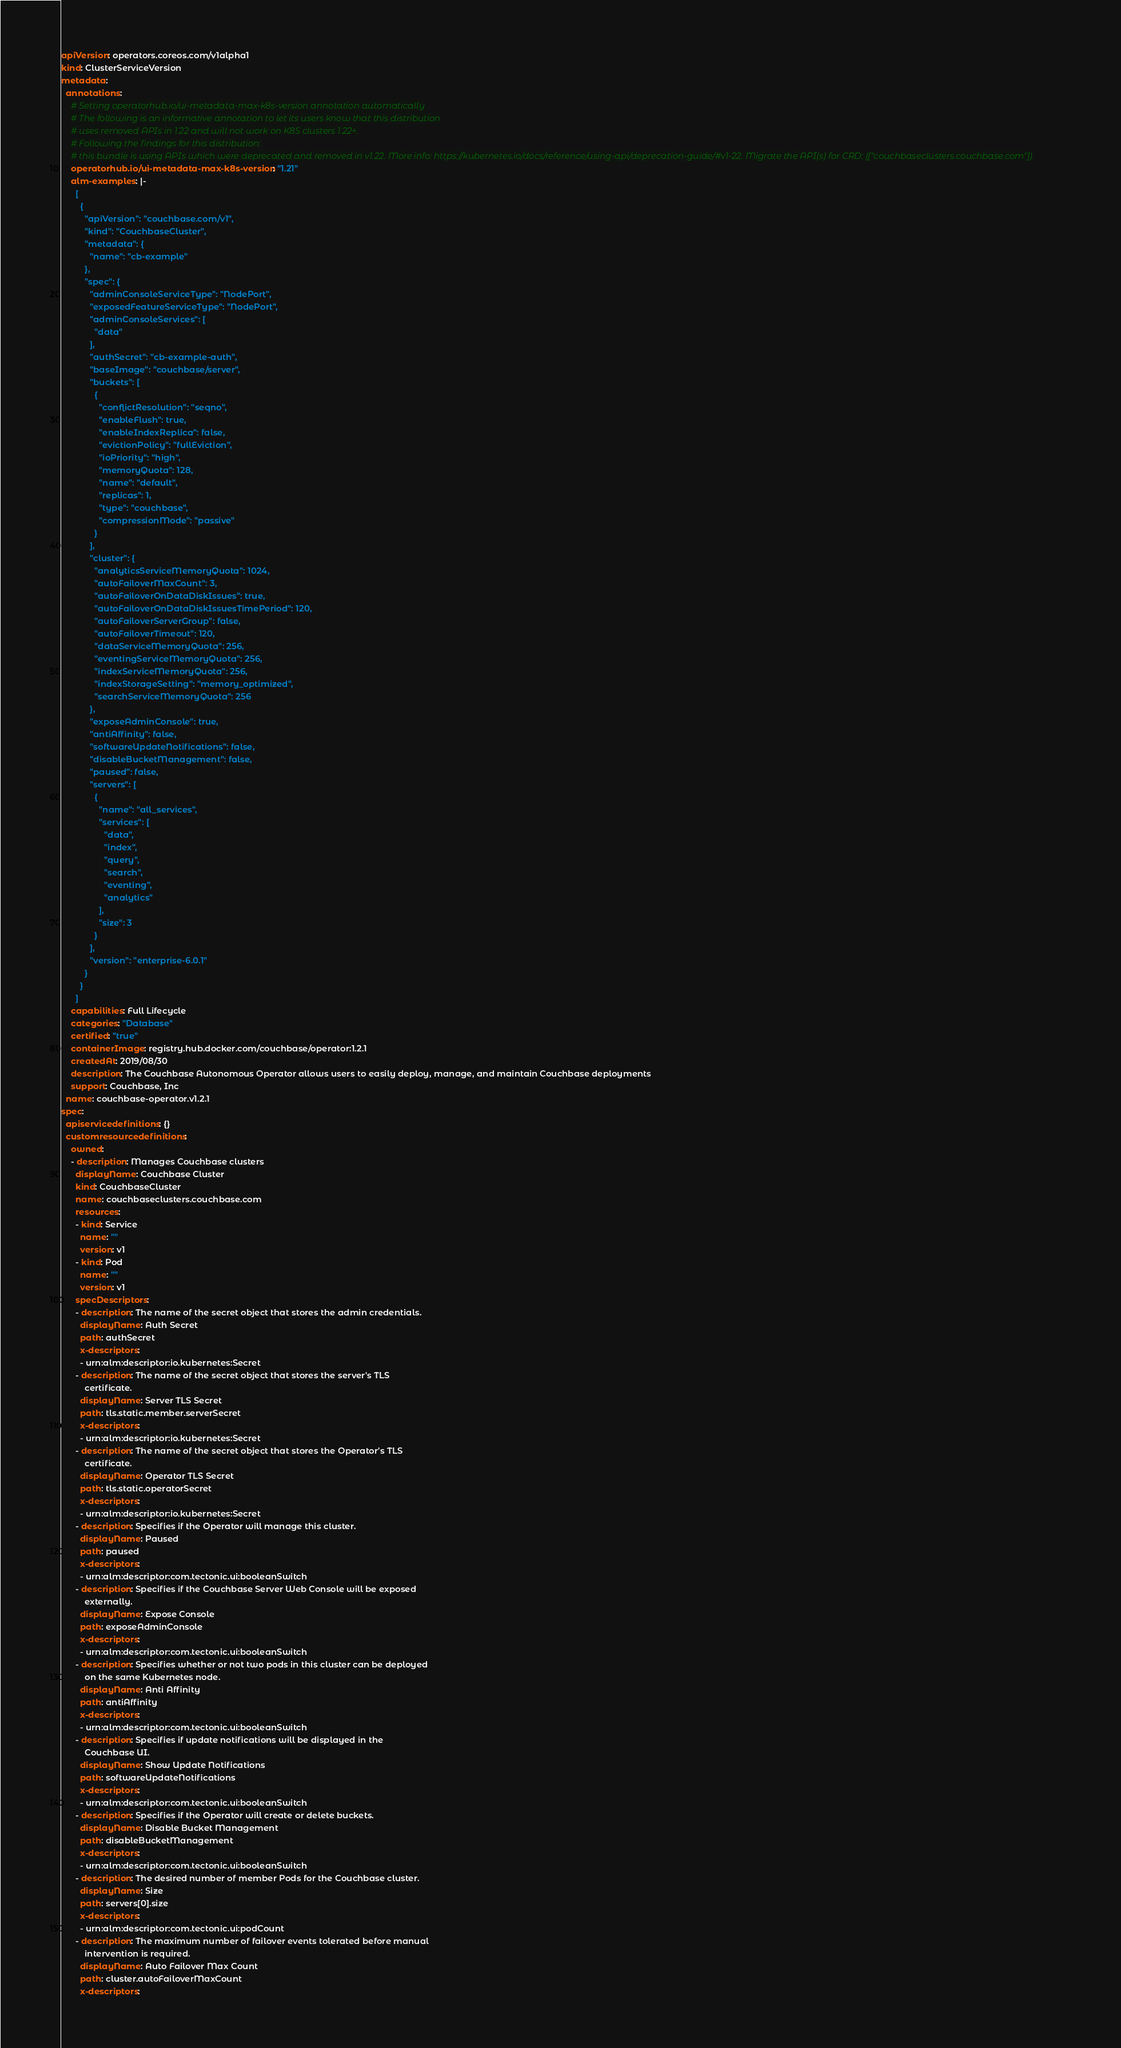Convert code to text. <code><loc_0><loc_0><loc_500><loc_500><_YAML_>apiVersion: operators.coreos.com/v1alpha1
kind: ClusterServiceVersion
metadata:
  annotations:
    # Setting operatorhub.io/ui-metadata-max-k8s-version annotation automatically
    # The following is an informative annotation to let its users know that this distribution
    # uses removed APIs in 1.22 and will not work on K8S clusters 1.22+.
    # Following the findings for this distribution:
    # this bundle is using APIs which were deprecated and removed in v1.22. More info: https://kubernetes.io/docs/reference/using-api/deprecation-guide/#v1-22. Migrate the API(s) for CRD: (["couchbaseclusters.couchbase.com"])
    operatorhub.io/ui-metadata-max-k8s-version: "1.21"
    alm-examples: |-
      [
        {
          "apiVersion": "couchbase.com/v1",
          "kind": "CouchbaseCluster",
          "metadata": {
            "name": "cb-example"
          },
          "spec": {
            "adminConsoleServiceType": "NodePort",
            "exposedFeatureServiceType": "NodePort",
            "adminConsoleServices": [
              "data"
            ],
            "authSecret": "cb-example-auth",
            "baseImage": "couchbase/server",
            "buckets": [
              {
                "conflictResolution": "seqno",
                "enableFlush": true,
                "enableIndexReplica": false,
                "evictionPolicy": "fullEviction",
                "ioPriority": "high",
                "memoryQuota": 128,
                "name": "default",
                "replicas": 1,
                "type": "couchbase",
                "compressionMode": "passive"
              }
            ],
            "cluster": {
              "analyticsServiceMemoryQuota": 1024,
              "autoFailoverMaxCount": 3,
              "autoFailoverOnDataDiskIssues": true,
              "autoFailoverOnDataDiskIssuesTimePeriod": 120,
              "autoFailoverServerGroup": false,
              "autoFailoverTimeout": 120,
              "dataServiceMemoryQuota": 256,
              "eventingServiceMemoryQuota": 256,
              "indexServiceMemoryQuota": 256,
              "indexStorageSetting": "memory_optimized",
              "searchServiceMemoryQuota": 256
            },
            "exposeAdminConsole": true,
            "antiAffinity": false,
            "softwareUpdateNotifications": false,
            "disableBucketManagement": false,
            "paused": false,
            "servers": [
              {
                "name": "all_services",
                "services": [
                  "data",
                  "index",
                  "query",
                  "search",
                  "eventing",
                  "analytics"
                ],
                "size": 3
              }
            ],
            "version": "enterprise-6.0.1"
          }
        }
      ]
    capabilities: Full Lifecycle
    categories: "Database"
    certified: "true"
    containerImage: registry.hub.docker.com/couchbase/operator:1.2.1
    createdAt: 2019/08/30
    description: The Couchbase Autonomous Operator allows users to easily deploy, manage, and maintain Couchbase deployments
    support: Couchbase, Inc
  name: couchbase-operator.v1.2.1
spec:
  apiservicedefinitions: {}
  customresourcedefinitions:
    owned:
    - description: Manages Couchbase clusters
      displayName: Couchbase Cluster
      kind: CouchbaseCluster
      name: couchbaseclusters.couchbase.com
      resources:
      - kind: Service
        name: ""
        version: v1
      - kind: Pod
        name: ""
        version: v1
      specDescriptors:
      - description: The name of the secret object that stores the admin credentials.
        displayName: Auth Secret
        path: authSecret
        x-descriptors:
        - urn:alm:descriptor:io.kubernetes:Secret
      - description: The name of the secret object that stores the server's TLS
          certificate.
        displayName: Server TLS Secret
        path: tls.static.member.serverSecret
        x-descriptors:
        - urn:alm:descriptor:io.kubernetes:Secret
      - description: The name of the secret object that stores the Operator's TLS
          certificate.
        displayName: Operator TLS Secret
        path: tls.static.operatorSecret
        x-descriptors:
        - urn:alm:descriptor:io.kubernetes:Secret
      - description: Specifies if the Operator will manage this cluster.
        displayName: Paused
        path: paused
        x-descriptors:
        - urn:alm:descriptor:com.tectonic.ui:booleanSwitch
      - description: Specifies if the Couchbase Server Web Console will be exposed
          externally.
        displayName: Expose Console
        path: exposeAdminConsole
        x-descriptors:
        - urn:alm:descriptor:com.tectonic.ui:booleanSwitch
      - description: Specifies whether or not two pods in this cluster can be deployed
          on the same Kubernetes node.
        displayName: Anti Affinity
        path: antiAffinity
        x-descriptors:
        - urn:alm:descriptor:com.tectonic.ui:booleanSwitch
      - description: Specifies if update notifications will be displayed in the
          Couchbase UI.
        displayName: Show Update Notifications
        path: softwareUpdateNotifications
        x-descriptors:
        - urn:alm:descriptor:com.tectonic.ui:booleanSwitch
      - description: Specifies if the Operator will create or delete buckets.
        displayName: Disable Bucket Management
        path: disableBucketManagement
        x-descriptors:
        - urn:alm:descriptor:com.tectonic.ui:booleanSwitch
      - description: The desired number of member Pods for the Couchbase cluster.
        displayName: Size
        path: servers[0].size
        x-descriptors:
        - urn:alm:descriptor:com.tectonic.ui:podCount
      - description: The maximum number of failover events tolerated before manual
          intervention is required.
        displayName: Auto Failover Max Count
        path: cluster.autoFailoverMaxCount
        x-descriptors:</code> 